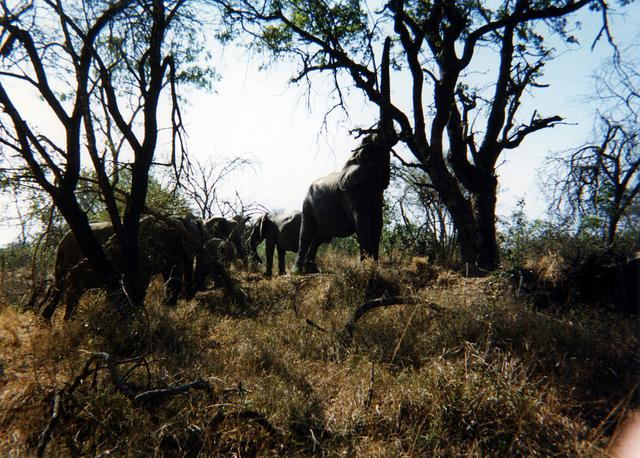In what setting are the animals? Please explain your reasoning. wilderness. The animals are in the wild. 